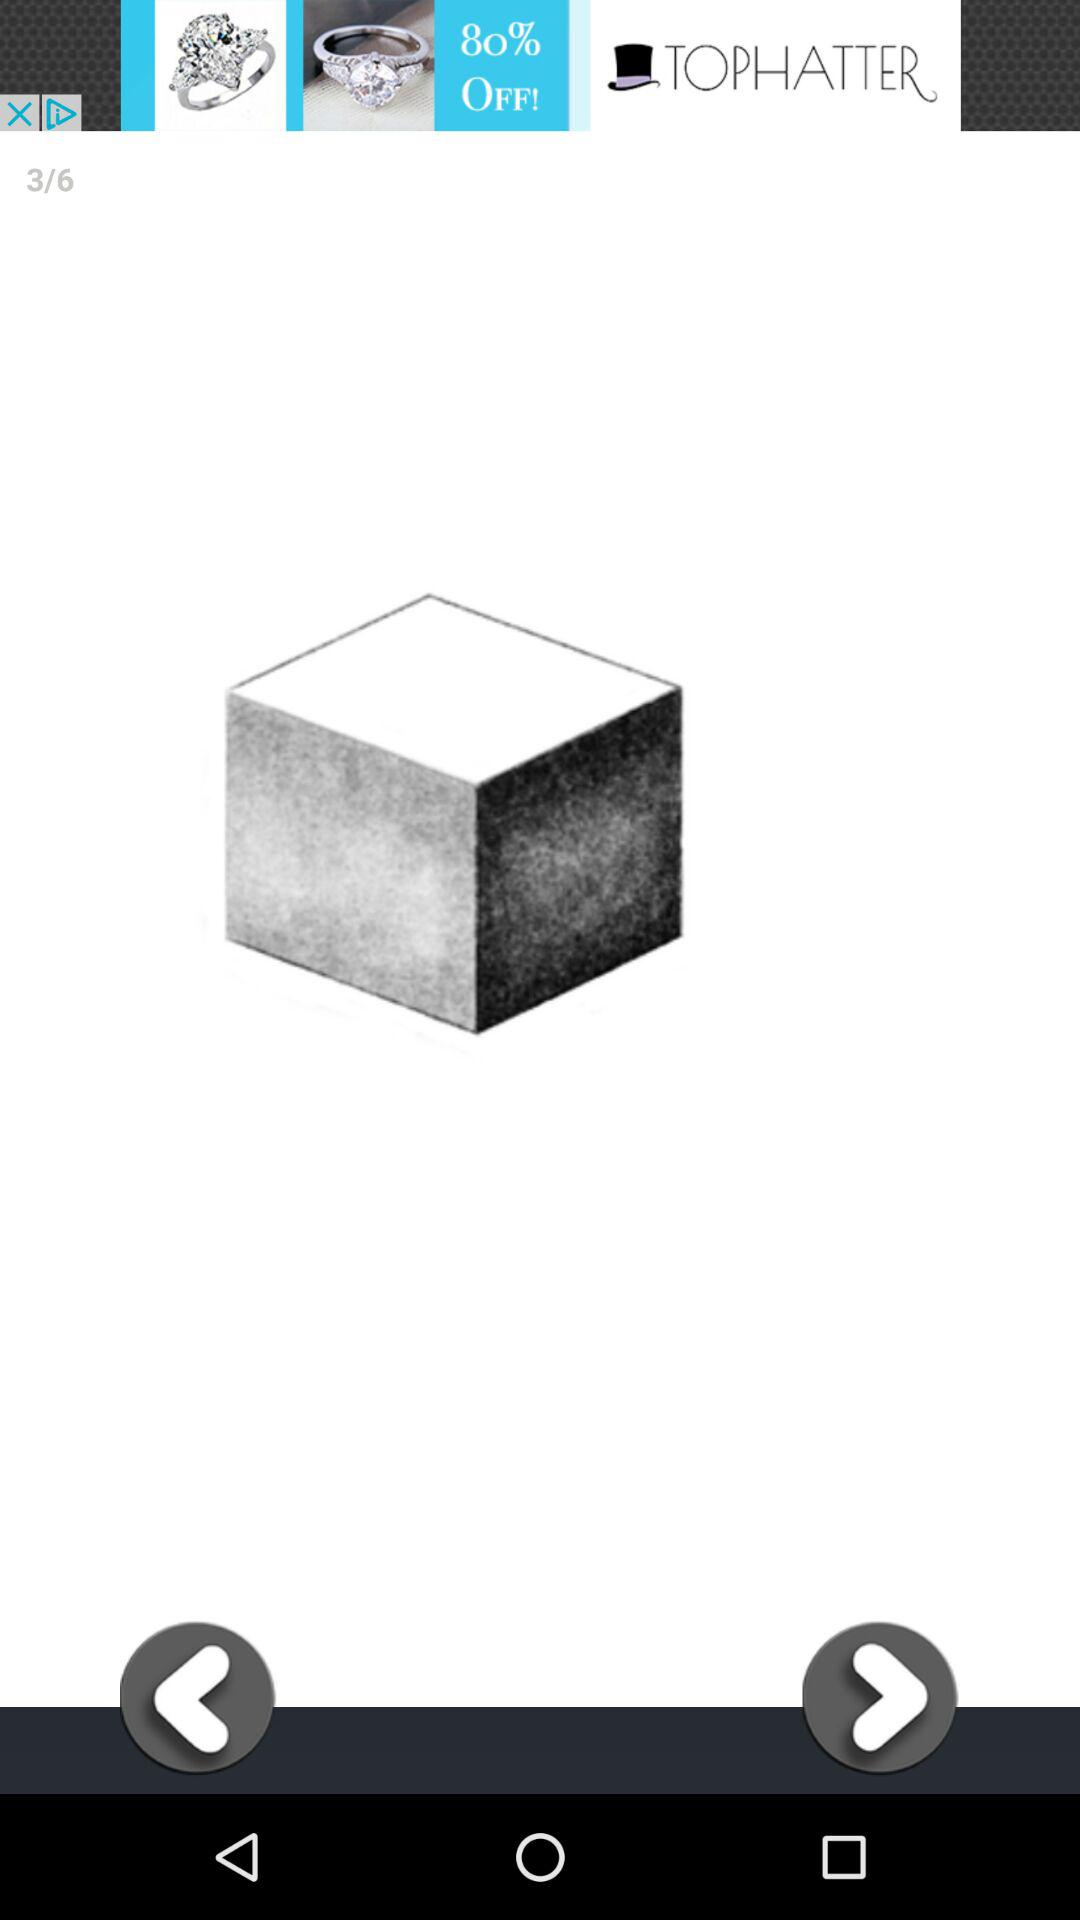How many images are there? There are 6 images. 